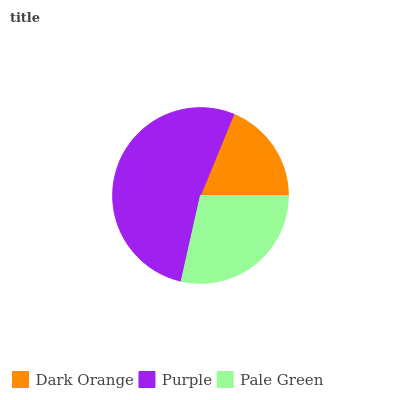Is Dark Orange the minimum?
Answer yes or no. Yes. Is Purple the maximum?
Answer yes or no. Yes. Is Pale Green the minimum?
Answer yes or no. No. Is Pale Green the maximum?
Answer yes or no. No. Is Purple greater than Pale Green?
Answer yes or no. Yes. Is Pale Green less than Purple?
Answer yes or no. Yes. Is Pale Green greater than Purple?
Answer yes or no. No. Is Purple less than Pale Green?
Answer yes or no. No. Is Pale Green the high median?
Answer yes or no. Yes. Is Pale Green the low median?
Answer yes or no. Yes. Is Purple the high median?
Answer yes or no. No. Is Dark Orange the low median?
Answer yes or no. No. 